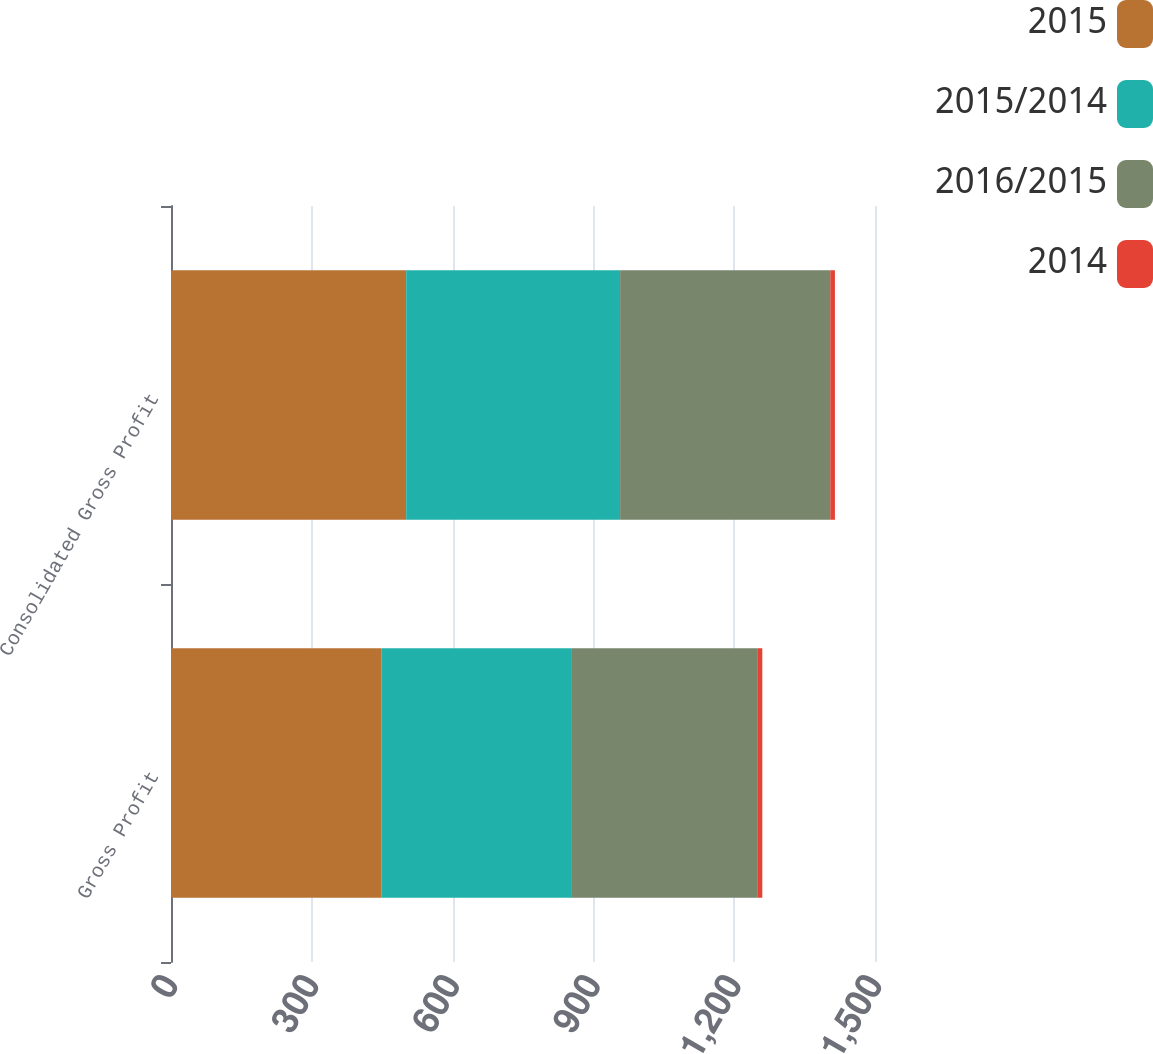<chart> <loc_0><loc_0><loc_500><loc_500><stacked_bar_chart><ecel><fcel>Gross Profit<fcel>Consolidated Gross Profit<nl><fcel>2015<fcel>448<fcel>501.1<nl><fcel>2015/2014<fcel>404.5<fcel>455.8<nl><fcel>2016/2015<fcel>396.6<fcel>447.8<nl><fcel>2014<fcel>10.8<fcel>9.9<nl></chart> 